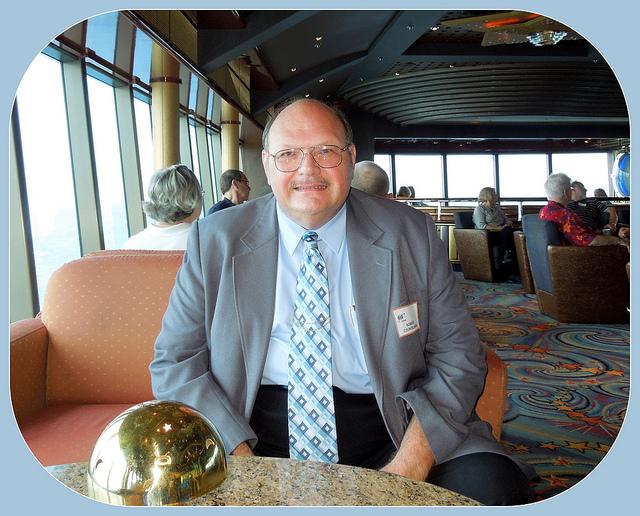Is the man wearing a badge on his jacket?
Short answer required. Yes. Is there anyone in the room who is not a senior citizen?
Answer briefly. No. What design is on the man's tie?
Write a very short answer. Diamonds. 